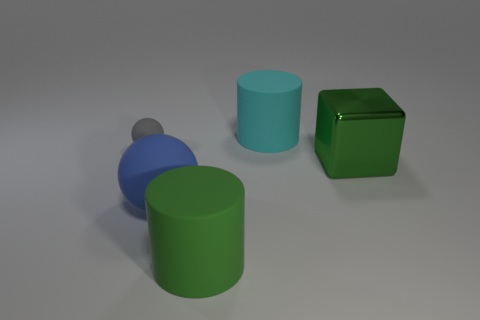There is a big thing that is on the right side of the large green rubber object and in front of the cyan cylinder; what is its shape?
Keep it short and to the point. Cube. How many tiny gray things are the same shape as the blue matte object?
Your answer should be compact. 1. There is a green object that is made of the same material as the big blue ball; what is its size?
Provide a succinct answer. Large. Are there more cyan cylinders than large rubber blocks?
Your response must be concise. Yes. There is a big matte cylinder behind the large shiny thing; what is its color?
Your answer should be very brief. Cyan. What is the size of the rubber object that is both behind the blue rubber sphere and to the right of the gray rubber sphere?
Offer a terse response. Large. How many green cylinders have the same size as the cyan cylinder?
Your answer should be very brief. 1. Is the gray thing the same shape as the cyan object?
Offer a terse response. No. How many large objects are in front of the big blue ball?
Make the answer very short. 1. There is a large green object to the left of the thing to the right of the cyan rubber cylinder; what shape is it?
Give a very brief answer. Cylinder. 